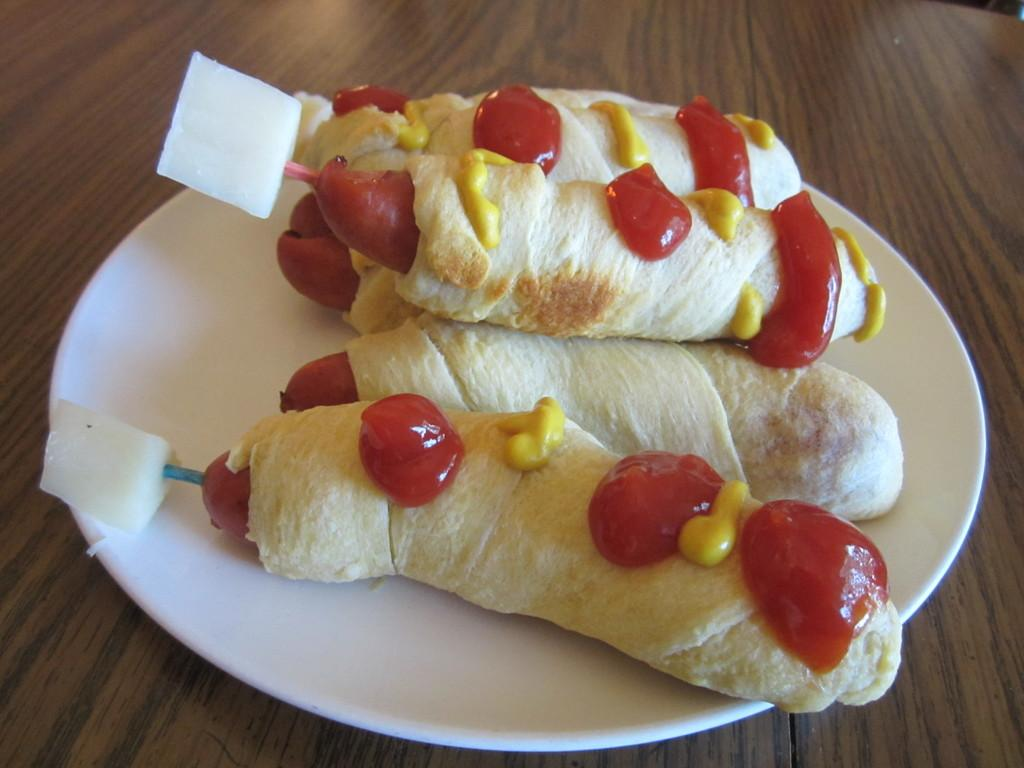What is on the plate that is visible in the image? There is a plate with food items in the image. What is the material of the surface on which the plate is placed? The plate is placed on a wooden surface. What type of steel is used to make the soap in the image? There is no soap or steel present in the image; it features a plate with food items placed on a wooden surface. 